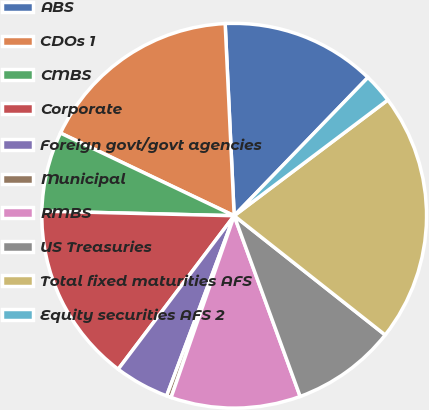Convert chart. <chart><loc_0><loc_0><loc_500><loc_500><pie_chart><fcel>ABS<fcel>CDOs 1<fcel>CMBS<fcel>Corporate<fcel>Foreign govt/govt agencies<fcel>Municipal<fcel>RMBS<fcel>US Treasuries<fcel>Total fixed maturities AFS<fcel>Equity securities AFS 2<nl><fcel>12.98%<fcel>17.18%<fcel>6.69%<fcel>15.08%<fcel>4.59%<fcel>0.39%<fcel>10.89%<fcel>8.79%<fcel>20.91%<fcel>2.49%<nl></chart> 